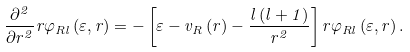<formula> <loc_0><loc_0><loc_500><loc_500>\frac { \partial ^ { 2 } } { \partial r ^ { 2 } } r \varphi _ { R l } \left ( \varepsilon , r \right ) = - \left [ \varepsilon - v _ { R } \left ( r \right ) - \frac { l \left ( l + 1 \right ) } { r ^ { 2 } } \right ] r \varphi _ { R l } \left ( \varepsilon , r \right ) .</formula> 